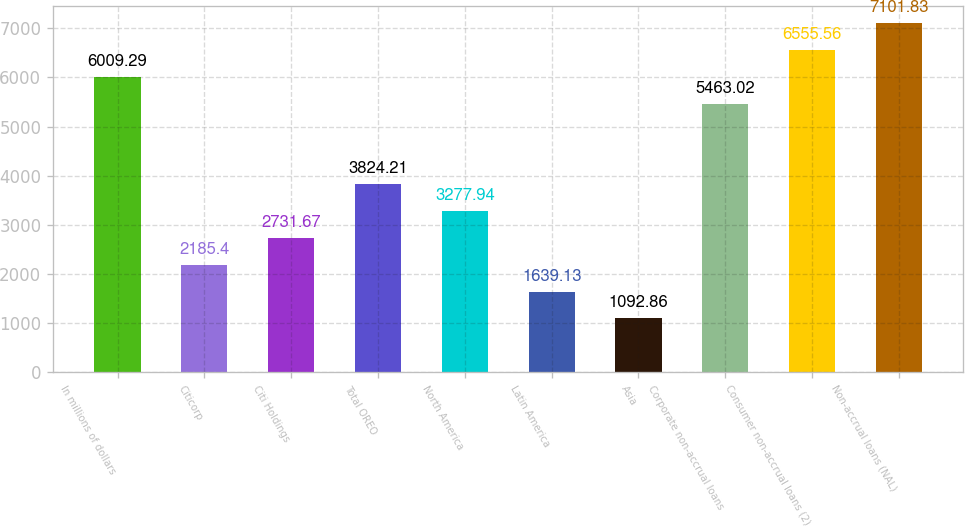Convert chart. <chart><loc_0><loc_0><loc_500><loc_500><bar_chart><fcel>In millions of dollars<fcel>Citicorp<fcel>Citi Holdings<fcel>Total OREO<fcel>North America<fcel>Latin America<fcel>Asia<fcel>Corporate non-accrual loans<fcel>Consumer non-accrual loans (2)<fcel>Non-accrual loans (NAL)<nl><fcel>6009.29<fcel>2185.4<fcel>2731.67<fcel>3824.21<fcel>3277.94<fcel>1639.13<fcel>1092.86<fcel>5463.02<fcel>6555.56<fcel>7101.83<nl></chart> 